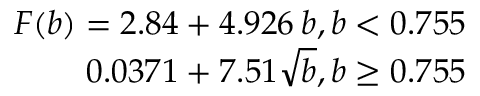<formula> <loc_0><loc_0><loc_500><loc_500>\begin{array} { r } { F ( b ) = 2 . 8 4 + 4 . 9 2 6 \, b , b < 0 . 7 5 5 } \\ { 0 . 0 3 7 1 + 7 . 5 1 \sqrt { b } , b \geq 0 . 7 5 5 } \end{array}</formula> 